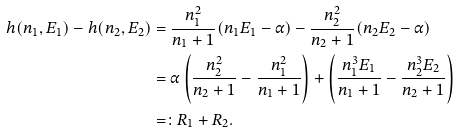<formula> <loc_0><loc_0><loc_500><loc_500>h ( n _ { 1 } , E _ { 1 } ) - h ( n _ { 2 } , E _ { 2 } ) & = \frac { n _ { 1 } ^ { 2 } } { n _ { 1 } + 1 } ( n _ { 1 } E _ { 1 } - \alpha ) - \frac { n _ { 2 } ^ { 2 } } { n _ { 2 } + 1 } ( n _ { 2 } E _ { 2 } - \alpha ) \\ & = \alpha \left ( \frac { n _ { 2 } ^ { 2 } } { n _ { 2 } + 1 } - \frac { n _ { 1 } ^ { 2 } } { n _ { 1 } + 1 } \right ) + \left ( \frac { n _ { 1 } ^ { 3 } E _ { 1 } } { n _ { 1 } + 1 } - \frac { n _ { 2 } ^ { 3 } E _ { 2 } } { n _ { 2 } + 1 } \right ) \\ & = \colon R _ { 1 } + R _ { 2 } .</formula> 